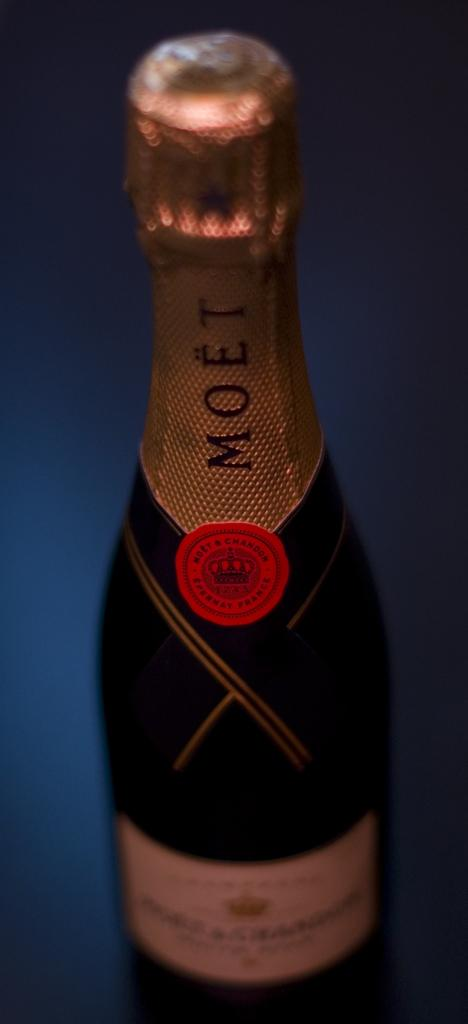<image>
Relay a brief, clear account of the picture shown. A bottle of Moet has a red seal sticker on it. 